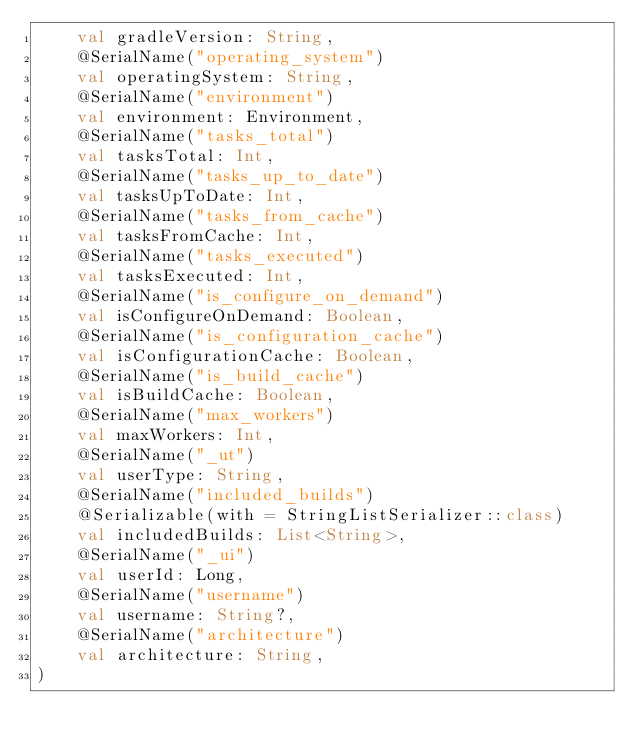<code> <loc_0><loc_0><loc_500><loc_500><_Kotlin_>    val gradleVersion: String,
    @SerialName("operating_system")
    val operatingSystem: String,
    @SerialName("environment")
    val environment: Environment,
    @SerialName("tasks_total")
    val tasksTotal: Int,
    @SerialName("tasks_up_to_date")
    val tasksUpToDate: Int,
    @SerialName("tasks_from_cache")
    val tasksFromCache: Int,
    @SerialName("tasks_executed")
    val tasksExecuted: Int,
    @SerialName("is_configure_on_demand")
    val isConfigureOnDemand: Boolean,
    @SerialName("is_configuration_cache")
    val isConfigurationCache: Boolean,
    @SerialName("is_build_cache")
    val isBuildCache: Boolean,
    @SerialName("max_workers")
    val maxWorkers: Int,
    @SerialName("_ut")
    val userType: String,
    @SerialName("included_builds")
    @Serializable(with = StringListSerializer::class)
    val includedBuilds: List<String>,
    @SerialName("_ui")
    val userId: Long,
    @SerialName("username")
    val username: String?,
    @SerialName("architecture")
    val architecture: String,
)
</code> 